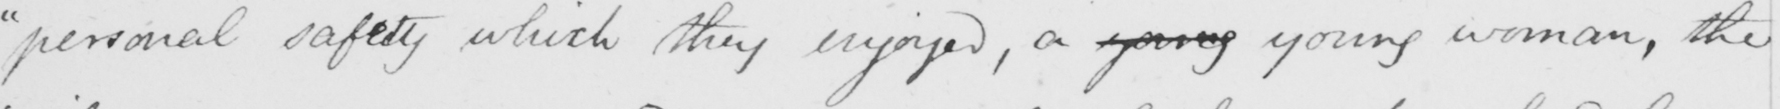Transcribe the text shown in this historical manuscript line. "personal safety which they enjoyed, a young young woman, the 